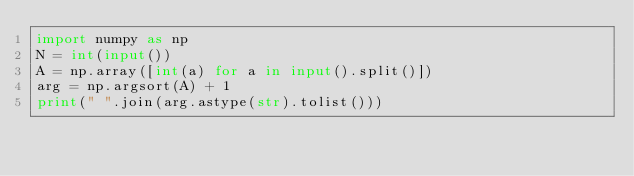Convert code to text. <code><loc_0><loc_0><loc_500><loc_500><_Python_>import numpy as np
N = int(input())
A = np.array([int(a) for a in input().split()])
arg = np.argsort(A) + 1
print(" ".join(arg.astype(str).tolist()))</code> 